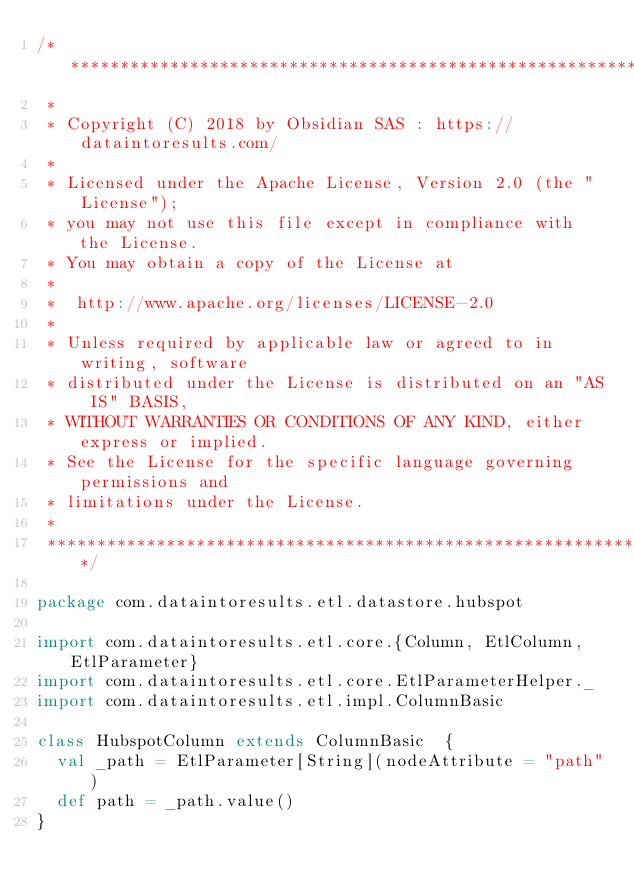Convert code to text. <code><loc_0><loc_0><loc_500><loc_500><_Scala_>/*******************************************************************************
 *
 * Copyright (C) 2018 by Obsidian SAS : https://dataintoresults.com/
 *
 * Licensed under the Apache License, Version 2.0 (the "License");
 * you may not use this file except in compliance with the License.
 * You may obtain a copy of the License at
 *
 *  http://www.apache.org/licenses/LICENSE-2.0
 *
 * Unless required by applicable law or agreed to in writing, software
 * distributed under the License is distributed on an "AS IS" BASIS,
 * WITHOUT WARRANTIES OR CONDITIONS OF ANY KIND, either express or implied.
 * See the License for the specific language governing permissions and
 * limitations under the License.
 *
 ******************************************************************************/

package com.dataintoresults.etl.datastore.hubspot

import com.dataintoresults.etl.core.{Column, EtlColumn, EtlParameter}
import com.dataintoresults.etl.core.EtlParameterHelper._
import com.dataintoresults.etl.impl.ColumnBasic

class HubspotColumn extends ColumnBasic  {
  val _path = EtlParameter[String](nodeAttribute = "path")
  def path = _path.value()
}
</code> 